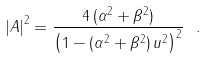<formula> <loc_0><loc_0><loc_500><loc_500>\left | A \right | ^ { 2 } = \frac { 4 \, ( \alpha ^ { 2 } + \beta ^ { 2 } ) } { \left ( 1 - ( \alpha ^ { 2 } + \beta ^ { 2 } ) \, u ^ { 2 } \right ) ^ { 2 } } \ .</formula> 